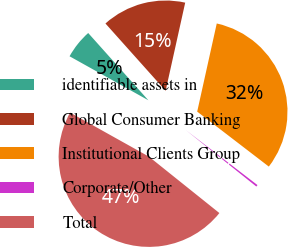Convert chart to OTSL. <chart><loc_0><loc_0><loc_500><loc_500><pie_chart><fcel>identifiable assets in<fcel>Global Consumer Banking<fcel>Institutional Clients Group<fcel>Corporate/Other<fcel>Total<nl><fcel>5.28%<fcel>15.09%<fcel>31.94%<fcel>0.33%<fcel>47.36%<nl></chart> 